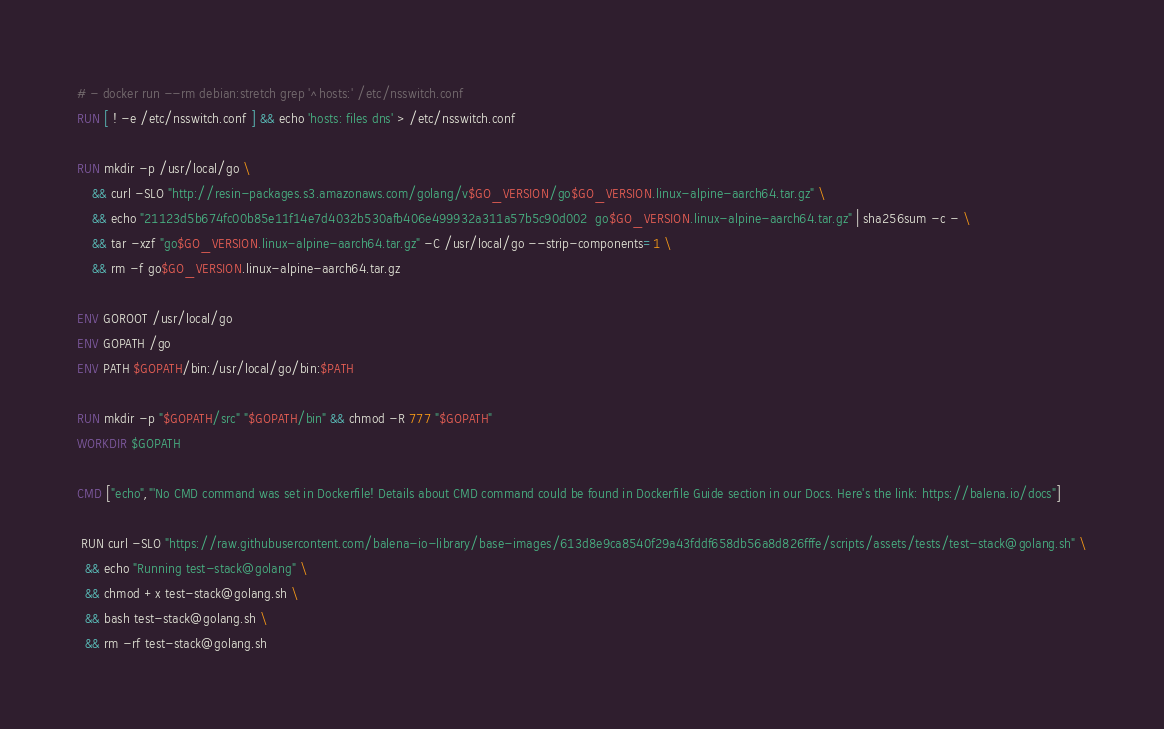<code> <loc_0><loc_0><loc_500><loc_500><_Dockerfile_># - docker run --rm debian:stretch grep '^hosts:' /etc/nsswitch.conf
RUN [ ! -e /etc/nsswitch.conf ] && echo 'hosts: files dns' > /etc/nsswitch.conf

RUN mkdir -p /usr/local/go \
	&& curl -SLO "http://resin-packages.s3.amazonaws.com/golang/v$GO_VERSION/go$GO_VERSION.linux-alpine-aarch64.tar.gz" \
	&& echo "21123d5b674fc00b85e11f14e7d4032b530afb406e499932a311a57b5c90d002  go$GO_VERSION.linux-alpine-aarch64.tar.gz" | sha256sum -c - \
	&& tar -xzf "go$GO_VERSION.linux-alpine-aarch64.tar.gz" -C /usr/local/go --strip-components=1 \
	&& rm -f go$GO_VERSION.linux-alpine-aarch64.tar.gz

ENV GOROOT /usr/local/go
ENV GOPATH /go
ENV PATH $GOPATH/bin:/usr/local/go/bin:$PATH

RUN mkdir -p "$GOPATH/src" "$GOPATH/bin" && chmod -R 777 "$GOPATH"
WORKDIR $GOPATH

CMD ["echo","'No CMD command was set in Dockerfile! Details about CMD command could be found in Dockerfile Guide section in our Docs. Here's the link: https://balena.io/docs"]

 RUN curl -SLO "https://raw.githubusercontent.com/balena-io-library/base-images/613d8e9ca8540f29a43fddf658db56a8d826fffe/scripts/assets/tests/test-stack@golang.sh" \
  && echo "Running test-stack@golang" \
  && chmod +x test-stack@golang.sh \
  && bash test-stack@golang.sh \
  && rm -rf test-stack@golang.sh 
</code> 